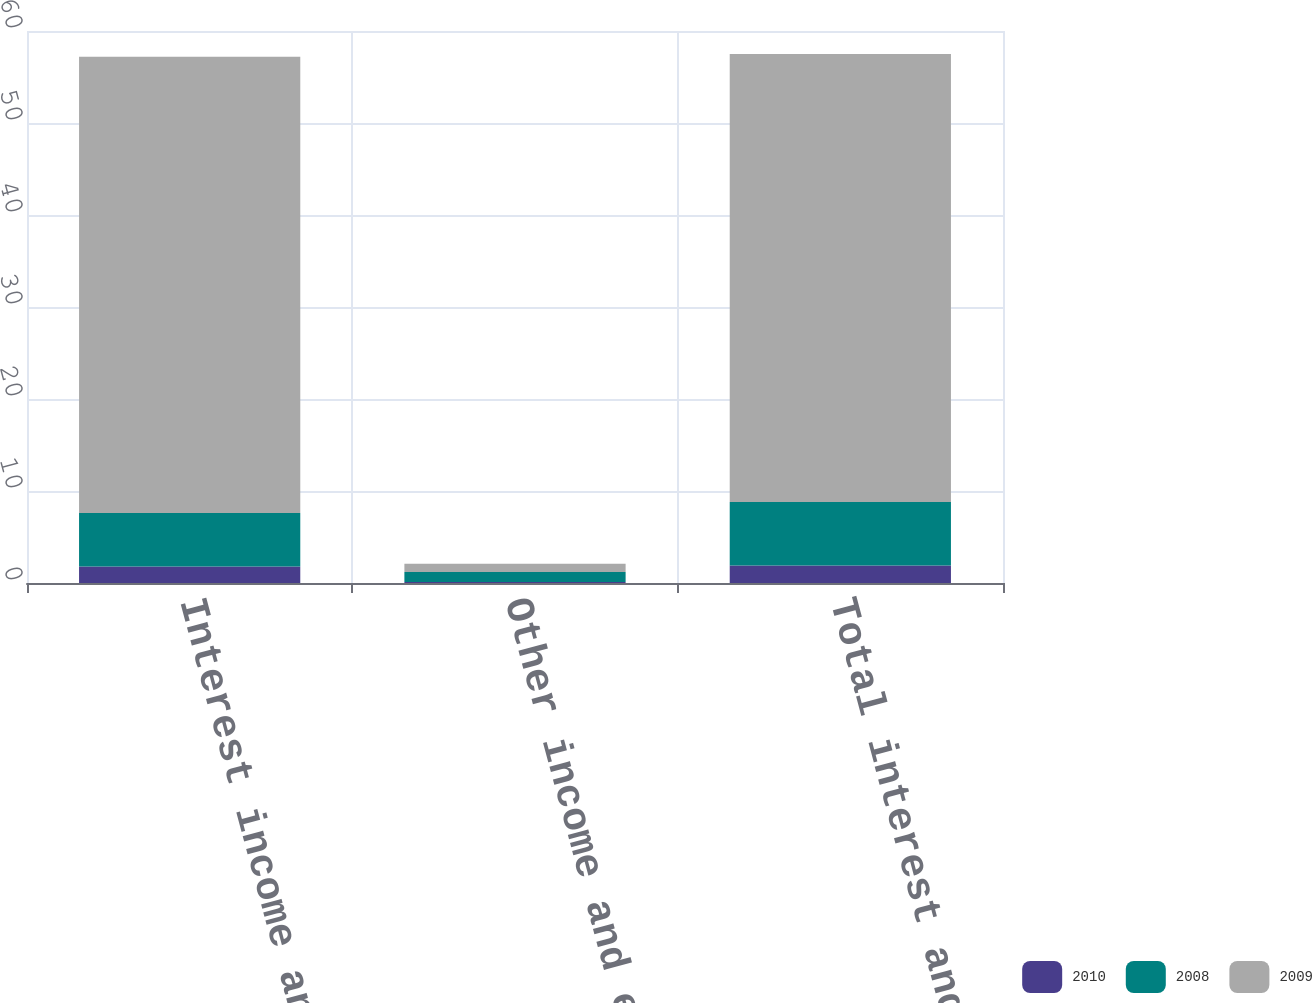Convert chart to OTSL. <chart><loc_0><loc_0><loc_500><loc_500><stacked_bar_chart><ecel><fcel>Interest income and expense<fcel>Other income and expense net<fcel>Total interest and other<nl><fcel>2010<fcel>1.8<fcel>0.1<fcel>1.9<nl><fcel>2008<fcel>5.8<fcel>1.1<fcel>6.9<nl><fcel>2009<fcel>49.6<fcel>0.9<fcel>48.7<nl></chart> 